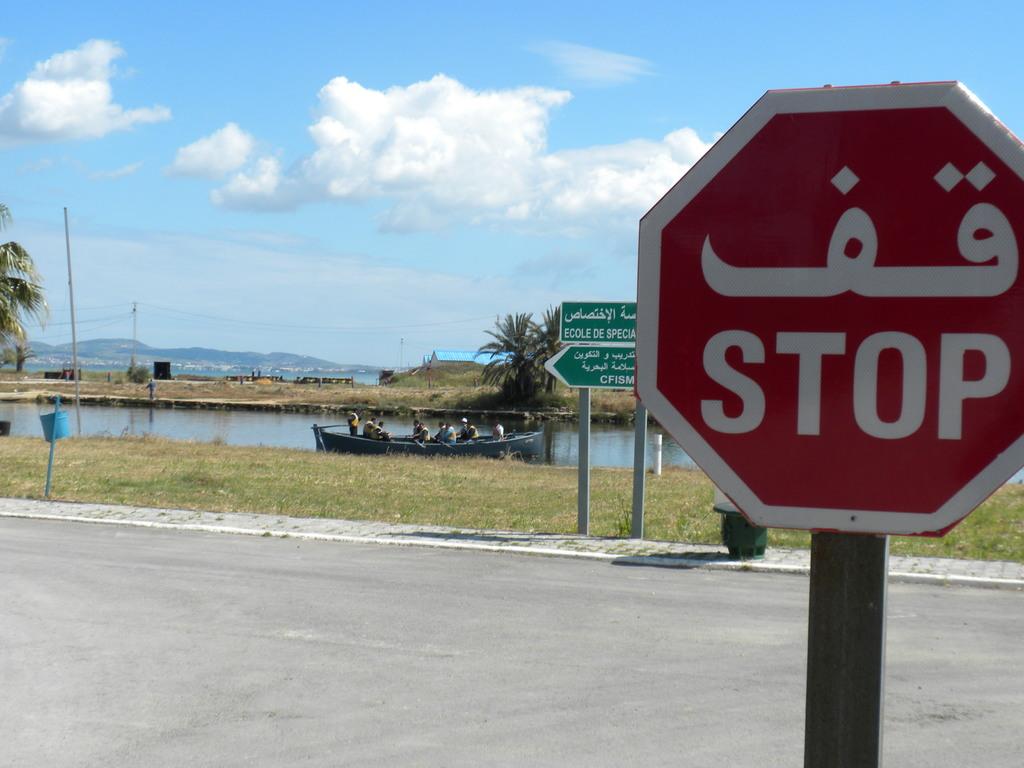What is the sign directing cars to do?
Give a very brief answer. Stop. What is the first word of the top green sign in the background?
Ensure brevity in your answer.  Ecole. 